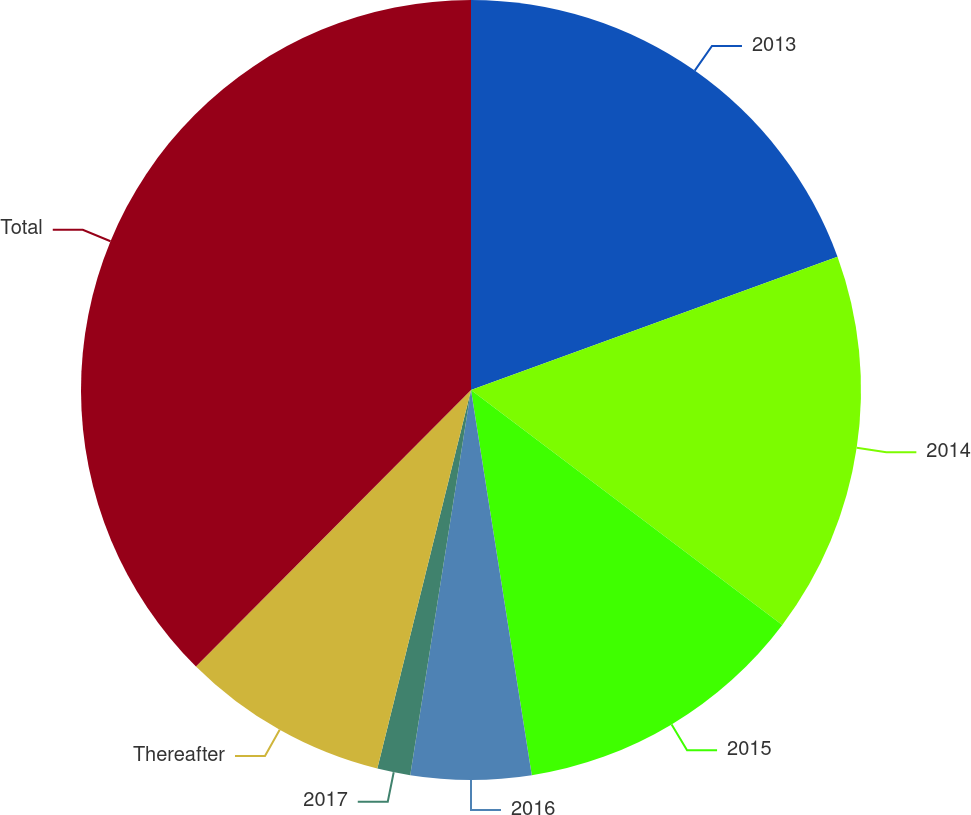<chart> <loc_0><loc_0><loc_500><loc_500><pie_chart><fcel>2013<fcel>2014<fcel>2015<fcel>2016<fcel>2017<fcel>Thereafter<fcel>Total<nl><fcel>19.45%<fcel>15.84%<fcel>12.22%<fcel>4.98%<fcel>1.37%<fcel>8.6%<fcel>37.54%<nl></chart> 